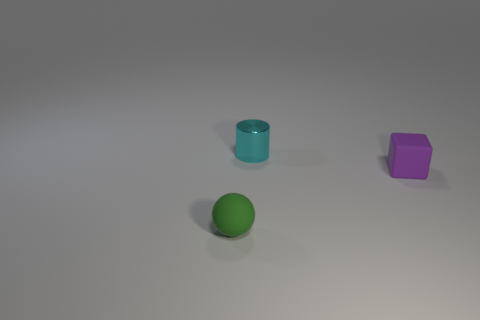Add 1 blocks. How many objects exist? 4 Subtract all blocks. How many objects are left? 2 Subtract 0 yellow blocks. How many objects are left? 3 Subtract all small green rubber objects. Subtract all small purple things. How many objects are left? 1 Add 3 tiny cyan cylinders. How many tiny cyan cylinders are left? 4 Add 1 big blue metal balls. How many big blue metal balls exist? 1 